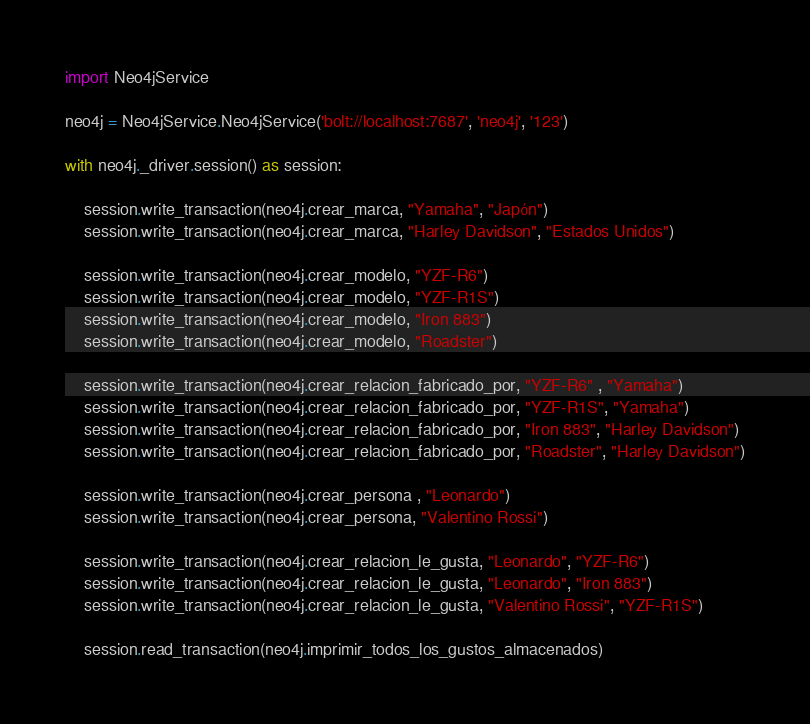Convert code to text. <code><loc_0><loc_0><loc_500><loc_500><_Python_>import Neo4jService

neo4j = Neo4jService.Neo4jService('bolt://localhost:7687', 'neo4j', '123')

with neo4j._driver.session() as session:

    session.write_transaction(neo4j.crear_marca, "Yamaha", "Japón")
    session.write_transaction(neo4j.crear_marca, "Harley Davidson", "Estados Unidos")

    session.write_transaction(neo4j.crear_modelo, "YZF-R6")
    session.write_transaction(neo4j.crear_modelo, "YZF-R1S")
    session.write_transaction(neo4j.crear_modelo, "Iron 883")
    session.write_transaction(neo4j.crear_modelo, "Roadster")

    session.write_transaction(neo4j.crear_relacion_fabricado_por, "YZF-R6" , "Yamaha")
    session.write_transaction(neo4j.crear_relacion_fabricado_por, "YZF-R1S", "Yamaha")
    session.write_transaction(neo4j.crear_relacion_fabricado_por, "Iron 883", "Harley Davidson")
    session.write_transaction(neo4j.crear_relacion_fabricado_por, "Roadster", "Harley Davidson")

    session.write_transaction(neo4j.crear_persona , "Leonardo")
    session.write_transaction(neo4j.crear_persona, "Valentino Rossi")

    session.write_transaction(neo4j.crear_relacion_le_gusta, "Leonardo", "YZF-R6")
    session.write_transaction(neo4j.crear_relacion_le_gusta, "Leonardo", "Iron 883")
    session.write_transaction(neo4j.crear_relacion_le_gusta, "Valentino Rossi", "YZF-R1S")

    session.read_transaction(neo4j.imprimir_todos_los_gustos_almacenados)
</code> 